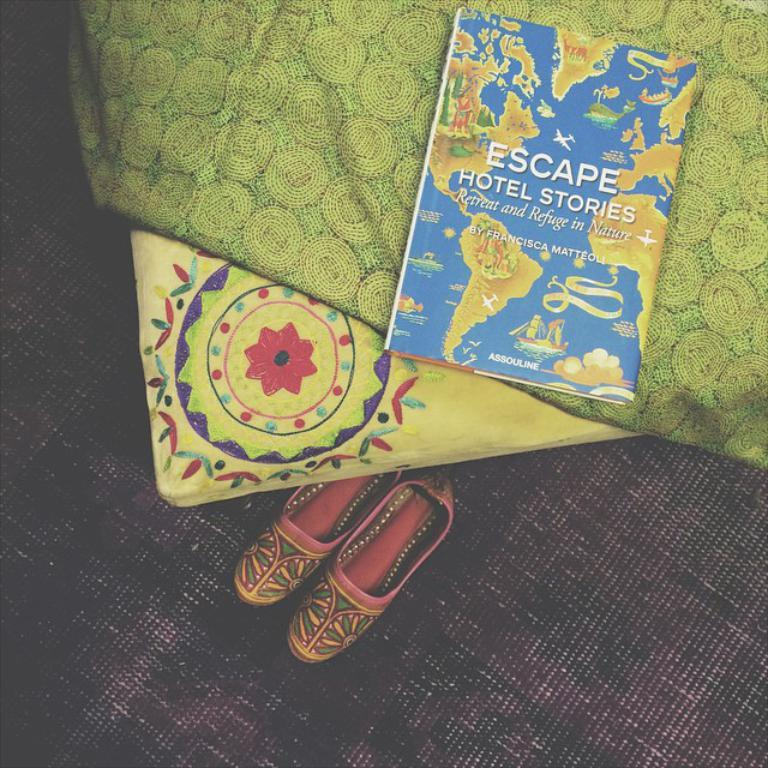<image>
Provide a brief description of the given image. Escape Hotel stories sits on bed next to a pair of shoe. 